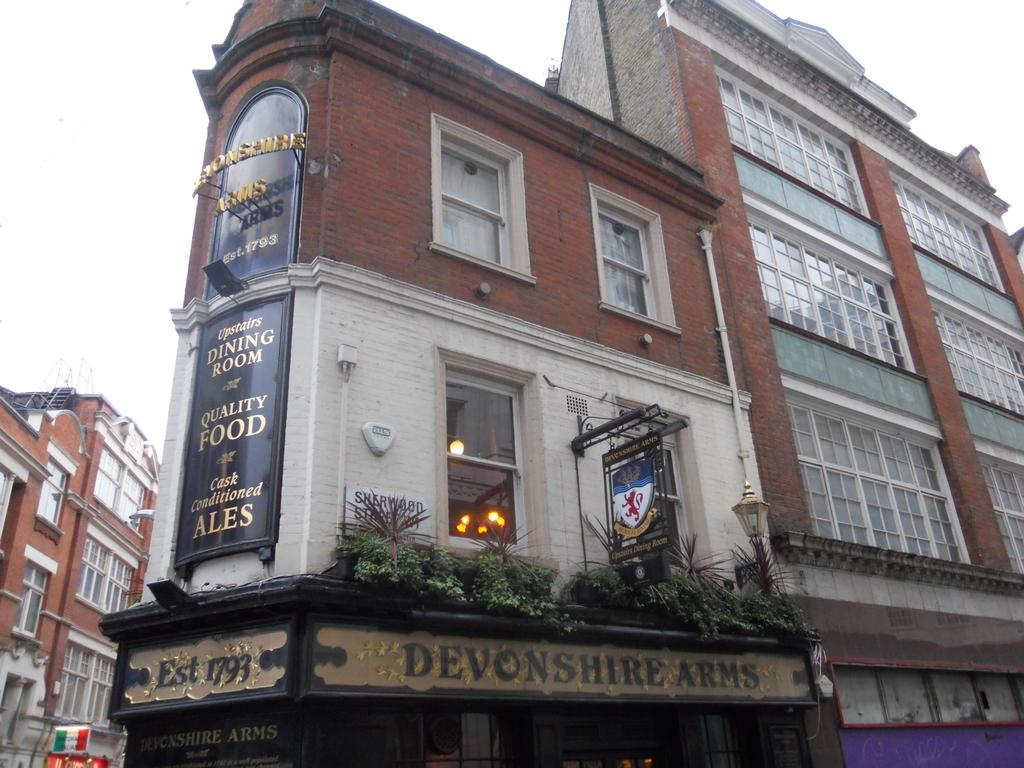What type of structures can be seen in the image? There are buildings in the image. What type of signage is present in the image? There are hoardings in the image. What type of illumination is visible in the image? There are lights in the image. What type of vegetation is present in the image? There are plants in the image. Where is the library located in the image? There is no library present in the image. What type of machine is being used to water the plants in the image? There is no machine present in the image; the plants are not being watered. 